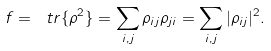Convert formula to latex. <formula><loc_0><loc_0><loc_500><loc_500>f = \ t r \{ \rho ^ { 2 } \} = \sum _ { i , j } \rho _ { i j } \rho _ { j i } = \sum _ { i , j } | \rho _ { i j } | ^ { 2 } .</formula> 